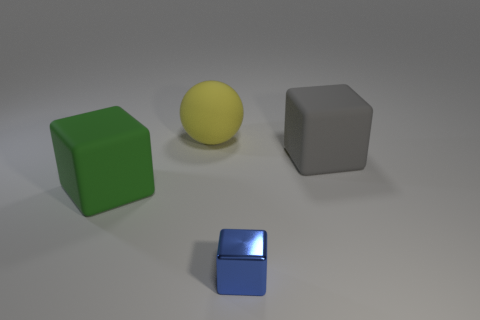Add 4 green objects. How many objects exist? 8 Subtract all spheres. How many objects are left? 3 Subtract 0 brown balls. How many objects are left? 4 Subtract all big gray matte things. Subtract all rubber blocks. How many objects are left? 1 Add 4 gray rubber objects. How many gray rubber objects are left? 5 Add 4 yellow rubber things. How many yellow rubber things exist? 5 